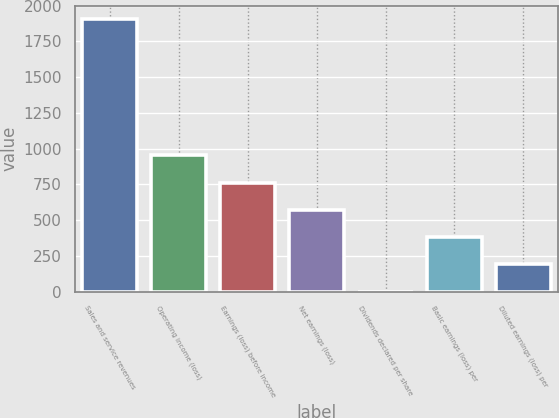<chart> <loc_0><loc_0><loc_500><loc_500><bar_chart><fcel>Sales and service revenues<fcel>Operating income (loss)<fcel>Earnings (loss) before income<fcel>Net earnings (loss)<fcel>Dividends declared per share<fcel>Basic earnings (loss) per<fcel>Diluted earnings (loss) per<nl><fcel>1905<fcel>952.75<fcel>762.3<fcel>571.85<fcel>0.5<fcel>381.4<fcel>190.95<nl></chart> 